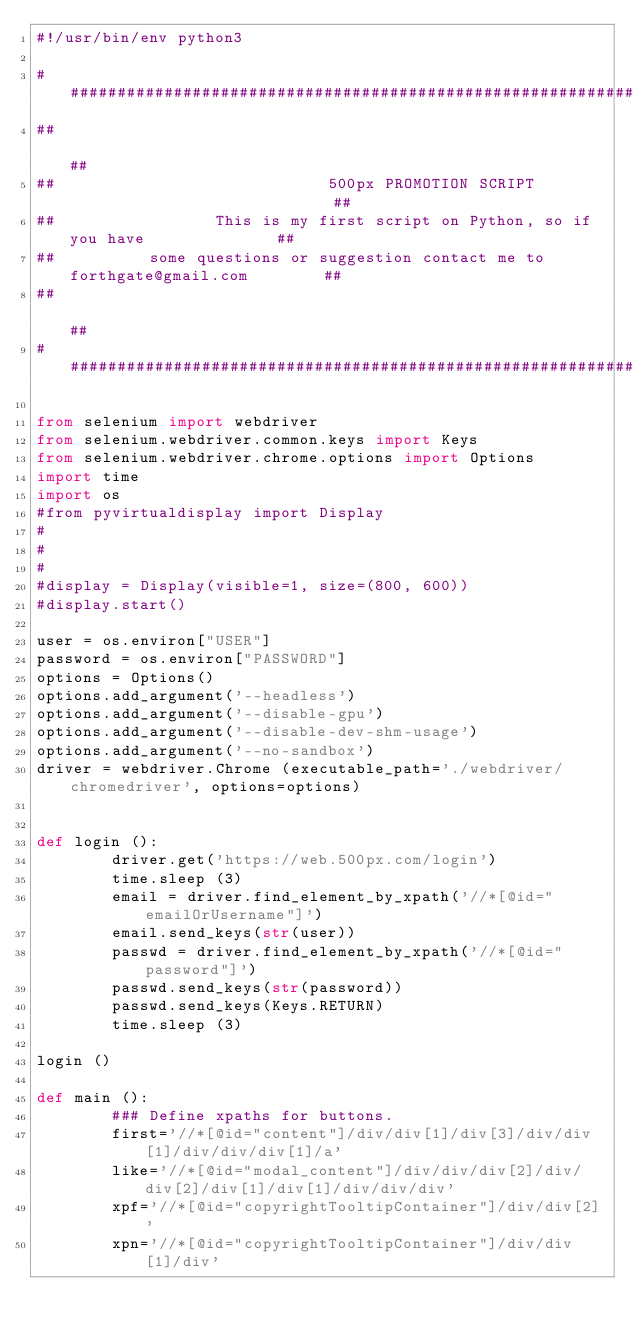<code> <loc_0><loc_0><loc_500><loc_500><_Python_>#!/usr/bin/env python3

####################################################################################
##                                                                                ##
##                             500px PROMOTION SCRIPT                             ##
##                 This is my first script on Python, so if you have              ##
##          some questions or suggestion contact me to forthgate@gmail.com        ##
##                                                                                ##
####################################################################################

from selenium import webdriver
from selenium.webdriver.common.keys import Keys
from selenium.webdriver.chrome.options import Options
import time
import os
#from pyvirtualdisplay import Display
#
#
#
#display = Display(visible=1, size=(800, 600))
#display.start()

user = os.environ["USER"]
password = os.environ["PASSWORD"]
options = Options()
options.add_argument('--headless')
options.add_argument('--disable-gpu')
options.add_argument('--disable-dev-shm-usage')
options.add_argument('--no-sandbox')
driver = webdriver.Chrome (executable_path='./webdriver/chromedriver', options=options)


def login ():
        driver.get('https://web.500px.com/login')
        time.sleep (3)
        email = driver.find_element_by_xpath('//*[@id="emailOrUsername"]')
        email.send_keys(str(user))
        passwd = driver.find_element_by_xpath('//*[@id="password"]')
        passwd.send_keys(str(password))
        passwd.send_keys(Keys.RETURN)
        time.sleep (3)

login ()

def main ():
        ### Define xpaths for buttons.
        first='//*[@id="content"]/div/div[1]/div[3]/div/div[1]/div/div/div[1]/a'
        like='//*[@id="modal_content"]/div/div/div[2]/div/div[2]/div[1]/div[1]/div/div/div'
        xpf='//*[@id="copyrightTooltipContainer"]/div/div[2]'
        xpn='//*[@id="copyrightTooltipContainer"]/div/div[1]/div'
</code> 